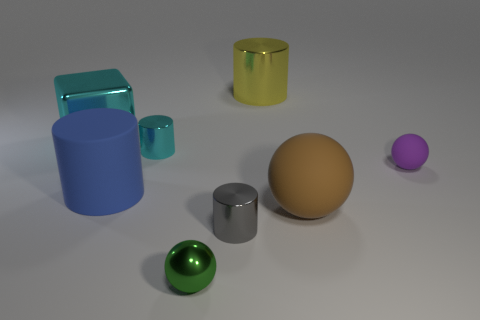Are there any large cyan things in front of the tiny purple thing?
Provide a succinct answer. No. How many objects are purple matte spheres to the right of the big brown ball or tiny matte spheres?
Keep it short and to the point. 1. What number of big cylinders are behind the big metal thing left of the tiny gray cylinder?
Give a very brief answer. 1. Is the number of blue matte things that are in front of the big brown rubber object less than the number of brown rubber balls that are behind the metal block?
Keep it short and to the point. No. What shape is the small shiny object that is behind the large rubber thing to the left of the yellow object?
Provide a short and direct response. Cylinder. How many other things are there of the same material as the small cyan object?
Provide a short and direct response. 4. Is there anything else that has the same size as the yellow thing?
Ensure brevity in your answer.  Yes. Are there more big rubber things than tiny cyan things?
Keep it short and to the point. Yes. How big is the brown matte object that is to the right of the big cylinder that is on the right side of the tiny thing to the left of the small green sphere?
Offer a very short reply. Large. Does the block have the same size as the metal object that is right of the small gray cylinder?
Provide a short and direct response. Yes. 